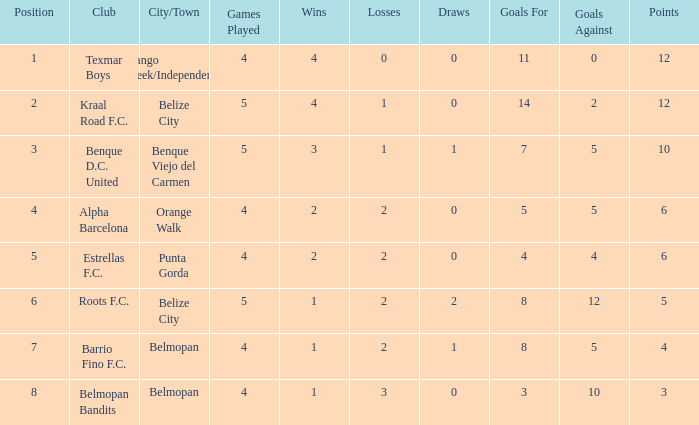Who is the the club (city/town) with goals for/against being 14-2 Kraal Road F.C. ( Belize City ). 